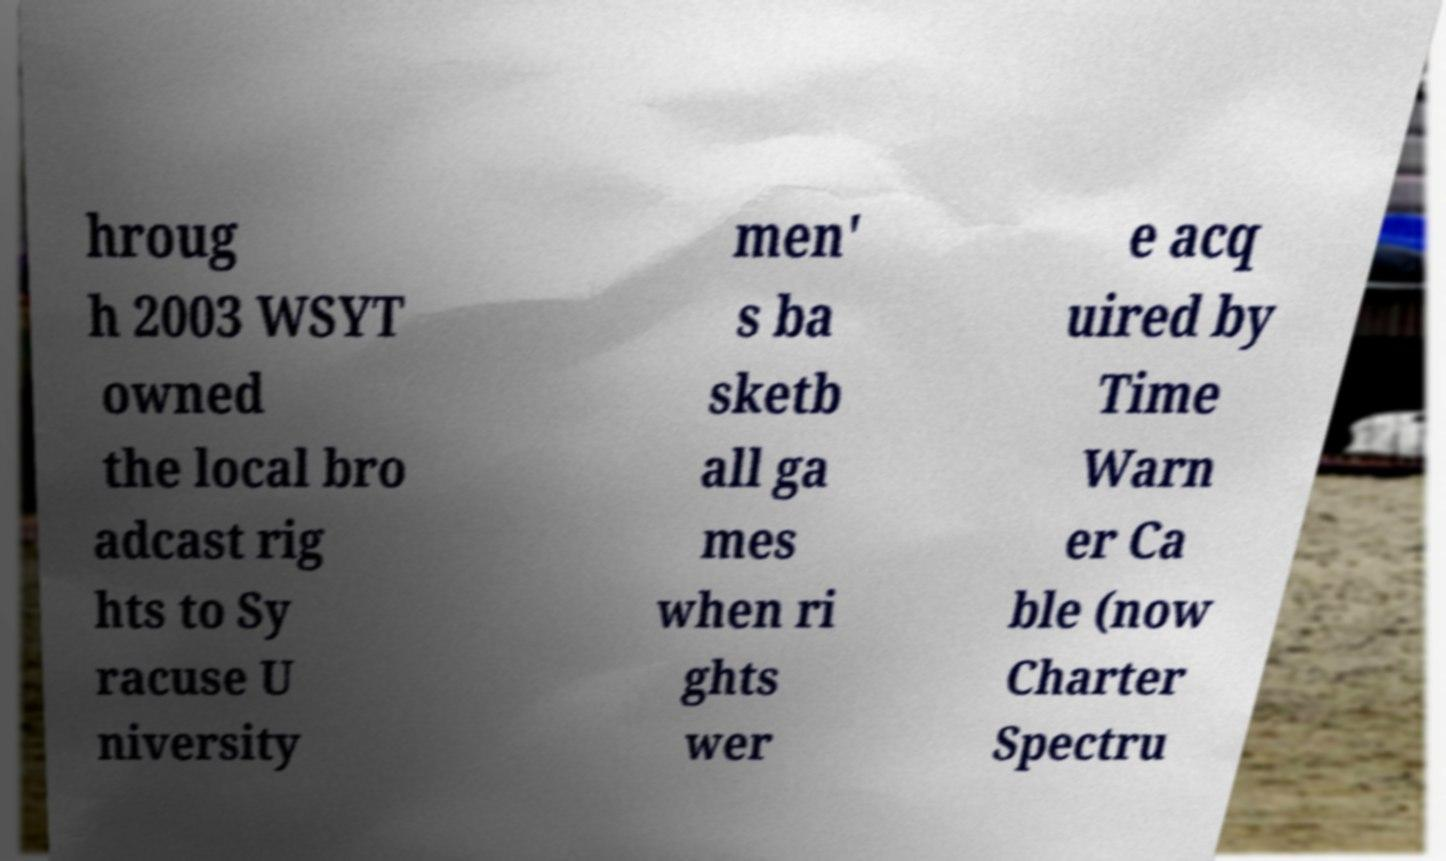There's text embedded in this image that I need extracted. Can you transcribe it verbatim? hroug h 2003 WSYT owned the local bro adcast rig hts to Sy racuse U niversity men' s ba sketb all ga mes when ri ghts wer e acq uired by Time Warn er Ca ble (now Charter Spectru 